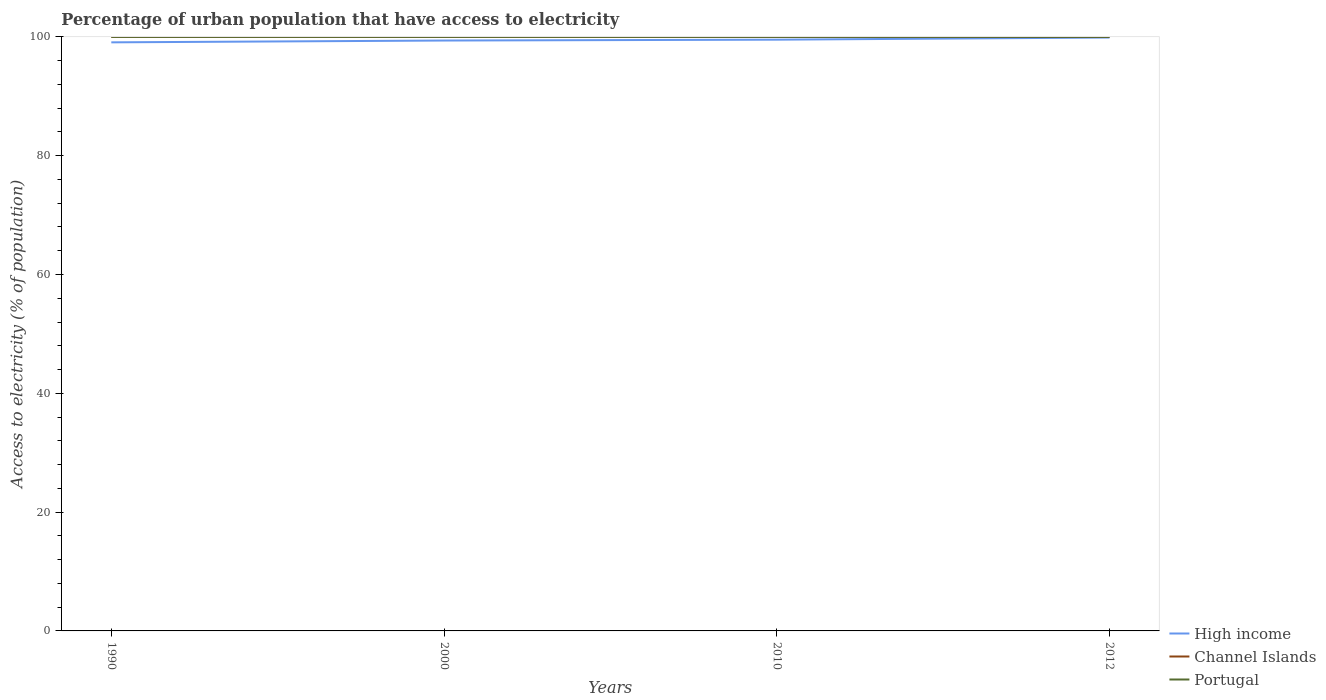How many different coloured lines are there?
Ensure brevity in your answer.  3. Does the line corresponding to Channel Islands intersect with the line corresponding to High income?
Make the answer very short. No. Across all years, what is the maximum percentage of urban population that have access to electricity in Channel Islands?
Make the answer very short. 100. What is the total percentage of urban population that have access to electricity in Channel Islands in the graph?
Give a very brief answer. 0. What is the difference between the highest and the second highest percentage of urban population that have access to electricity in High income?
Give a very brief answer. 0.81. How many lines are there?
Provide a succinct answer. 3. How many years are there in the graph?
Provide a succinct answer. 4. What is the difference between two consecutive major ticks on the Y-axis?
Your response must be concise. 20. Are the values on the major ticks of Y-axis written in scientific E-notation?
Ensure brevity in your answer.  No. Does the graph contain grids?
Your answer should be very brief. No. Where does the legend appear in the graph?
Ensure brevity in your answer.  Bottom right. How many legend labels are there?
Offer a very short reply. 3. How are the legend labels stacked?
Your response must be concise. Vertical. What is the title of the graph?
Offer a terse response. Percentage of urban population that have access to electricity. What is the label or title of the Y-axis?
Your answer should be compact. Access to electricity (% of population). What is the Access to electricity (% of population) of High income in 1990?
Provide a succinct answer. 99.07. What is the Access to electricity (% of population) of Channel Islands in 1990?
Your response must be concise. 100. What is the Access to electricity (% of population) in Portugal in 1990?
Keep it short and to the point. 100. What is the Access to electricity (% of population) of High income in 2000?
Your answer should be very brief. 99.38. What is the Access to electricity (% of population) of Channel Islands in 2000?
Offer a very short reply. 100. What is the Access to electricity (% of population) of High income in 2010?
Give a very brief answer. 99.53. What is the Access to electricity (% of population) of High income in 2012?
Keep it short and to the point. 99.89. Across all years, what is the maximum Access to electricity (% of population) of High income?
Provide a succinct answer. 99.89. Across all years, what is the minimum Access to electricity (% of population) of High income?
Provide a short and direct response. 99.07. What is the total Access to electricity (% of population) in High income in the graph?
Keep it short and to the point. 397.87. What is the total Access to electricity (% of population) of Channel Islands in the graph?
Give a very brief answer. 400. What is the total Access to electricity (% of population) in Portugal in the graph?
Keep it short and to the point. 400. What is the difference between the Access to electricity (% of population) in High income in 1990 and that in 2000?
Your answer should be compact. -0.31. What is the difference between the Access to electricity (% of population) of Channel Islands in 1990 and that in 2000?
Your answer should be compact. 0. What is the difference between the Access to electricity (% of population) in Portugal in 1990 and that in 2000?
Make the answer very short. 0. What is the difference between the Access to electricity (% of population) in High income in 1990 and that in 2010?
Your answer should be very brief. -0.45. What is the difference between the Access to electricity (% of population) of Portugal in 1990 and that in 2010?
Give a very brief answer. 0. What is the difference between the Access to electricity (% of population) of High income in 1990 and that in 2012?
Offer a very short reply. -0.81. What is the difference between the Access to electricity (% of population) in High income in 2000 and that in 2010?
Give a very brief answer. -0.14. What is the difference between the Access to electricity (% of population) of Channel Islands in 2000 and that in 2010?
Give a very brief answer. 0. What is the difference between the Access to electricity (% of population) in Portugal in 2000 and that in 2010?
Give a very brief answer. 0. What is the difference between the Access to electricity (% of population) in High income in 2000 and that in 2012?
Provide a short and direct response. -0.5. What is the difference between the Access to electricity (% of population) of High income in 2010 and that in 2012?
Provide a succinct answer. -0.36. What is the difference between the Access to electricity (% of population) in Portugal in 2010 and that in 2012?
Keep it short and to the point. 0. What is the difference between the Access to electricity (% of population) of High income in 1990 and the Access to electricity (% of population) of Channel Islands in 2000?
Offer a terse response. -0.93. What is the difference between the Access to electricity (% of population) in High income in 1990 and the Access to electricity (% of population) in Portugal in 2000?
Provide a short and direct response. -0.93. What is the difference between the Access to electricity (% of population) of High income in 1990 and the Access to electricity (% of population) of Channel Islands in 2010?
Offer a very short reply. -0.93. What is the difference between the Access to electricity (% of population) of High income in 1990 and the Access to electricity (% of population) of Portugal in 2010?
Make the answer very short. -0.93. What is the difference between the Access to electricity (% of population) in High income in 1990 and the Access to electricity (% of population) in Channel Islands in 2012?
Offer a very short reply. -0.93. What is the difference between the Access to electricity (% of population) of High income in 1990 and the Access to electricity (% of population) of Portugal in 2012?
Offer a terse response. -0.93. What is the difference between the Access to electricity (% of population) of Channel Islands in 1990 and the Access to electricity (% of population) of Portugal in 2012?
Give a very brief answer. 0. What is the difference between the Access to electricity (% of population) of High income in 2000 and the Access to electricity (% of population) of Channel Islands in 2010?
Provide a succinct answer. -0.62. What is the difference between the Access to electricity (% of population) in High income in 2000 and the Access to electricity (% of population) in Portugal in 2010?
Keep it short and to the point. -0.62. What is the difference between the Access to electricity (% of population) in Channel Islands in 2000 and the Access to electricity (% of population) in Portugal in 2010?
Provide a succinct answer. 0. What is the difference between the Access to electricity (% of population) of High income in 2000 and the Access to electricity (% of population) of Channel Islands in 2012?
Keep it short and to the point. -0.62. What is the difference between the Access to electricity (% of population) of High income in 2000 and the Access to electricity (% of population) of Portugal in 2012?
Ensure brevity in your answer.  -0.62. What is the difference between the Access to electricity (% of population) of Channel Islands in 2000 and the Access to electricity (% of population) of Portugal in 2012?
Give a very brief answer. 0. What is the difference between the Access to electricity (% of population) in High income in 2010 and the Access to electricity (% of population) in Channel Islands in 2012?
Your response must be concise. -0.47. What is the difference between the Access to electricity (% of population) in High income in 2010 and the Access to electricity (% of population) in Portugal in 2012?
Make the answer very short. -0.47. What is the difference between the Access to electricity (% of population) of Channel Islands in 2010 and the Access to electricity (% of population) of Portugal in 2012?
Give a very brief answer. 0. What is the average Access to electricity (% of population) of High income per year?
Your answer should be compact. 99.47. In the year 1990, what is the difference between the Access to electricity (% of population) of High income and Access to electricity (% of population) of Channel Islands?
Your answer should be compact. -0.93. In the year 1990, what is the difference between the Access to electricity (% of population) of High income and Access to electricity (% of population) of Portugal?
Your answer should be very brief. -0.93. In the year 2000, what is the difference between the Access to electricity (% of population) in High income and Access to electricity (% of population) in Channel Islands?
Your answer should be compact. -0.62. In the year 2000, what is the difference between the Access to electricity (% of population) in High income and Access to electricity (% of population) in Portugal?
Offer a very short reply. -0.62. In the year 2000, what is the difference between the Access to electricity (% of population) in Channel Islands and Access to electricity (% of population) in Portugal?
Provide a succinct answer. 0. In the year 2010, what is the difference between the Access to electricity (% of population) of High income and Access to electricity (% of population) of Channel Islands?
Ensure brevity in your answer.  -0.47. In the year 2010, what is the difference between the Access to electricity (% of population) of High income and Access to electricity (% of population) of Portugal?
Ensure brevity in your answer.  -0.47. In the year 2012, what is the difference between the Access to electricity (% of population) of High income and Access to electricity (% of population) of Channel Islands?
Your answer should be compact. -0.11. In the year 2012, what is the difference between the Access to electricity (% of population) of High income and Access to electricity (% of population) of Portugal?
Provide a succinct answer. -0.11. What is the ratio of the Access to electricity (% of population) of Portugal in 1990 to that in 2000?
Ensure brevity in your answer.  1. What is the ratio of the Access to electricity (% of population) of Channel Islands in 1990 to that in 2010?
Keep it short and to the point. 1. What is the ratio of the Access to electricity (% of population) in High income in 1990 to that in 2012?
Provide a short and direct response. 0.99. What is the ratio of the Access to electricity (% of population) of Channel Islands in 1990 to that in 2012?
Give a very brief answer. 1. What is the ratio of the Access to electricity (% of population) in Channel Islands in 2000 to that in 2010?
Provide a succinct answer. 1. What is the ratio of the Access to electricity (% of population) in Channel Islands in 2000 to that in 2012?
Make the answer very short. 1. What is the ratio of the Access to electricity (% of population) of High income in 2010 to that in 2012?
Keep it short and to the point. 1. What is the ratio of the Access to electricity (% of population) in Channel Islands in 2010 to that in 2012?
Your answer should be very brief. 1. What is the difference between the highest and the second highest Access to electricity (% of population) in High income?
Provide a succinct answer. 0.36. What is the difference between the highest and the lowest Access to electricity (% of population) of High income?
Your response must be concise. 0.81. What is the difference between the highest and the lowest Access to electricity (% of population) of Channel Islands?
Offer a terse response. 0. 